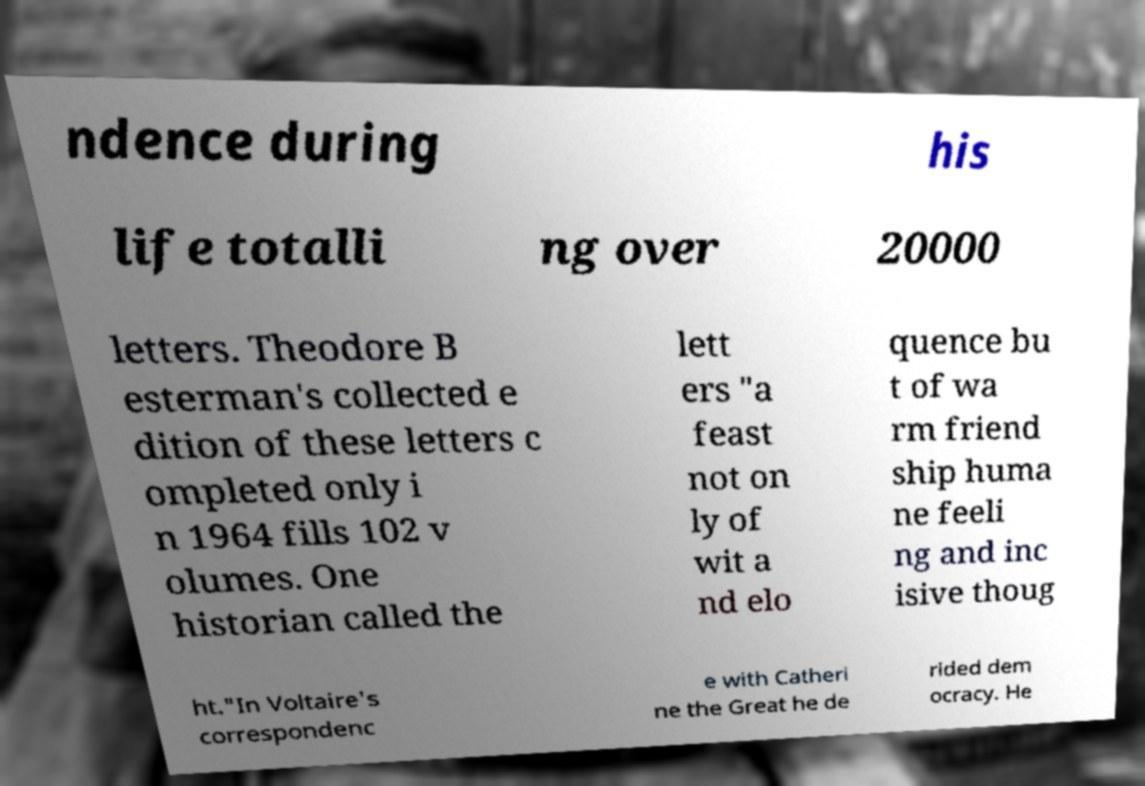Can you accurately transcribe the text from the provided image for me? ndence during his life totalli ng over 20000 letters. Theodore B esterman's collected e dition of these letters c ompleted only i n 1964 fills 102 v olumes. One historian called the lett ers "a feast not on ly of wit a nd elo quence bu t of wa rm friend ship huma ne feeli ng and inc isive thoug ht."In Voltaire's correspondenc e with Catheri ne the Great he de rided dem ocracy. He 